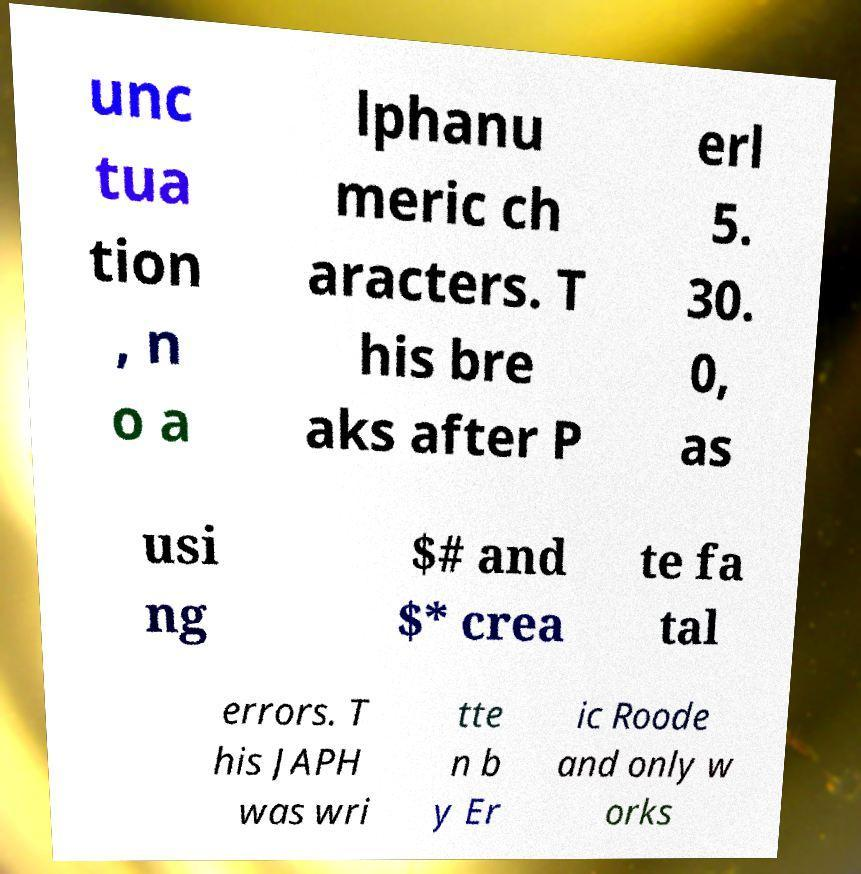Could you assist in decoding the text presented in this image and type it out clearly? unc tua tion , n o a lphanu meric ch aracters. T his bre aks after P erl 5. 30. 0, as usi ng $# and $* crea te fa tal errors. T his JAPH was wri tte n b y Er ic Roode and only w orks 